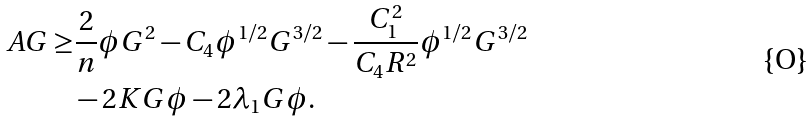Convert formula to latex. <formula><loc_0><loc_0><loc_500><loc_500>A G \geq & \frac { 2 } { n } \phi G ^ { 2 } - C _ { 4 } \phi ^ { 1 / 2 } G ^ { 3 / 2 } - \frac { C _ { 1 } ^ { 2 } } { C _ { 4 } R ^ { 2 } } \phi ^ { 1 / 2 } G ^ { 3 / 2 } \\ & - 2 K G \phi - 2 \lambda _ { 1 } G \phi .</formula> 